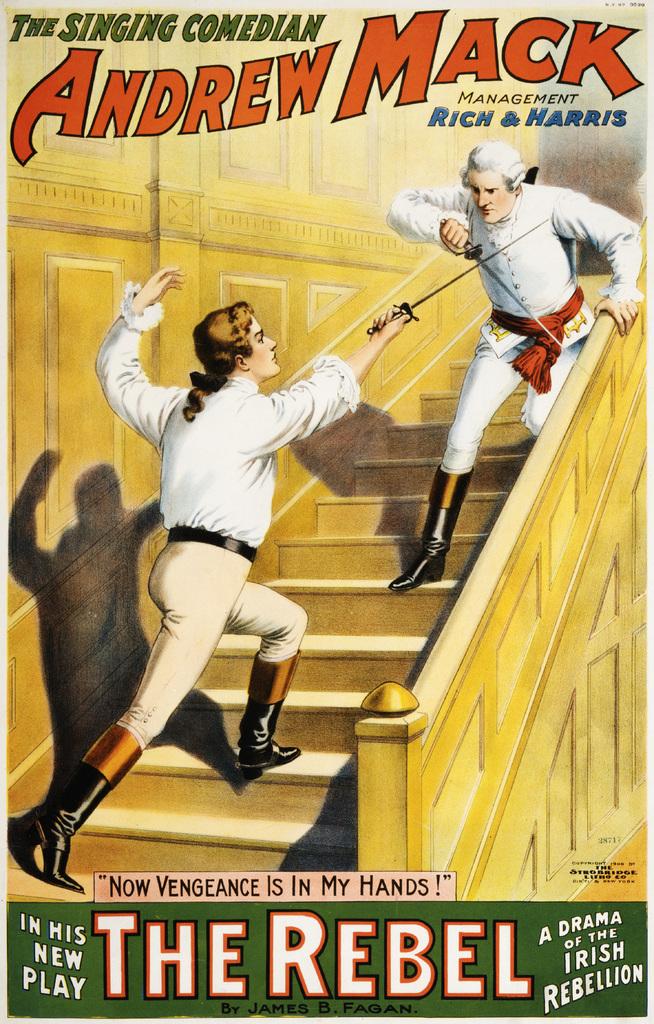What is the name of the singing comedian?
Make the answer very short. Andrew mack. What is the play's name?
Offer a very short reply. The rebel. 